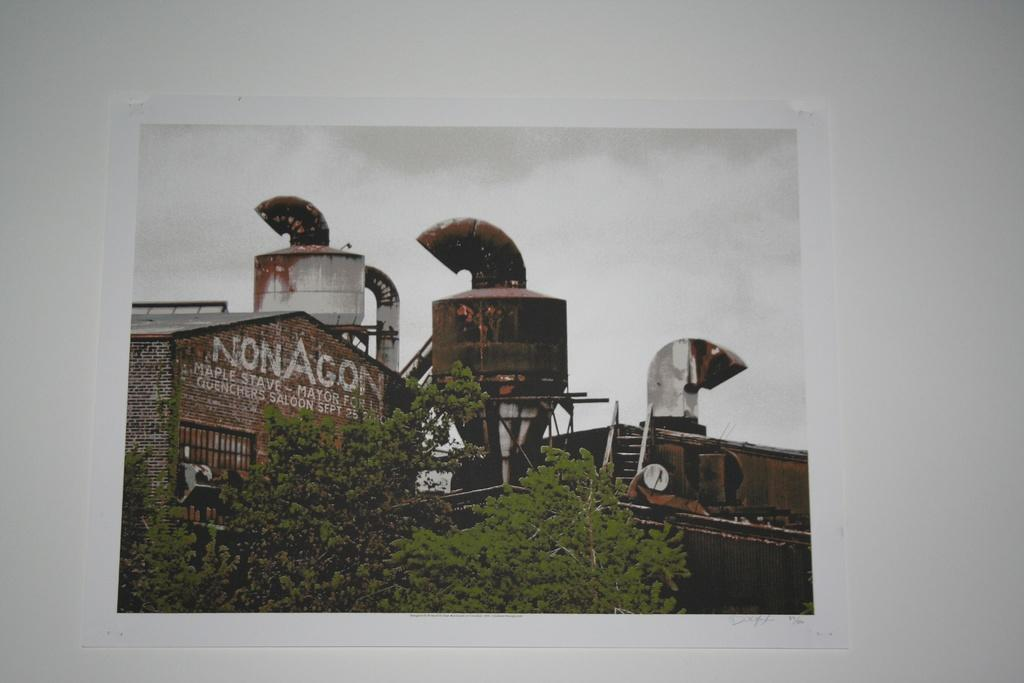<image>
Give a short and clear explanation of the subsequent image. a building with the word nonagon at the top of it 